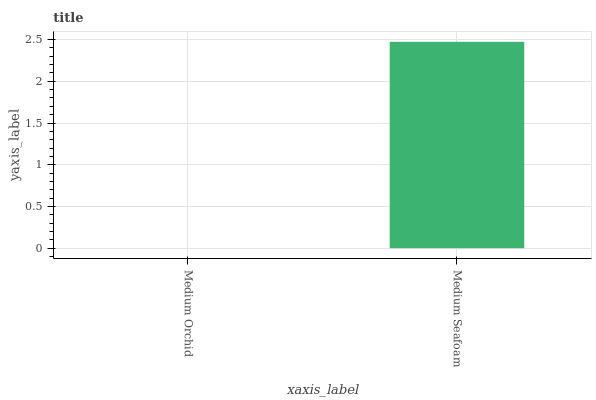Is Medium Orchid the minimum?
Answer yes or no. Yes. Is Medium Seafoam the maximum?
Answer yes or no. Yes. Is Medium Seafoam the minimum?
Answer yes or no. No. Is Medium Seafoam greater than Medium Orchid?
Answer yes or no. Yes. Is Medium Orchid less than Medium Seafoam?
Answer yes or no. Yes. Is Medium Orchid greater than Medium Seafoam?
Answer yes or no. No. Is Medium Seafoam less than Medium Orchid?
Answer yes or no. No. Is Medium Seafoam the high median?
Answer yes or no. Yes. Is Medium Orchid the low median?
Answer yes or no. Yes. Is Medium Orchid the high median?
Answer yes or no. No. Is Medium Seafoam the low median?
Answer yes or no. No. 